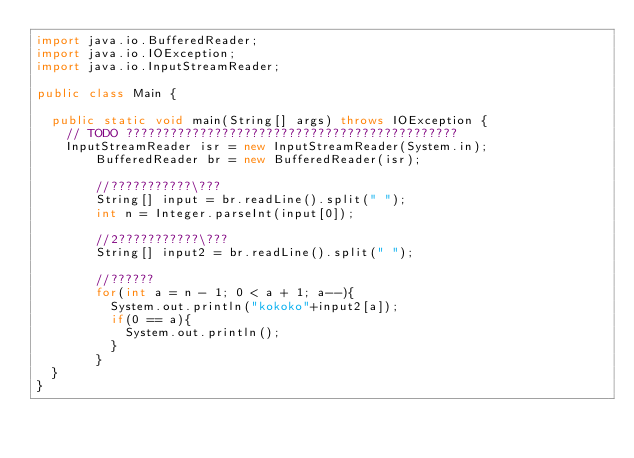Convert code to text. <code><loc_0><loc_0><loc_500><loc_500><_Java_>import java.io.BufferedReader;
import java.io.IOException;
import java.io.InputStreamReader;

public class Main {

	public static void main(String[] args) throws IOException {
		// TODO ?????????????????????????????????????????????
		InputStreamReader isr = new InputStreamReader(System.in);
        BufferedReader br = new BufferedReader(isr);

        //???????????\???
        String[] input = br.readLine().split(" ");
        int n = Integer.parseInt(input[0]);

        //2???????????\???
        String[] input2 = br.readLine().split(" ");

        //??????
        for(int a = n - 1; 0 < a + 1; a--){
        	System.out.println("kokoko"+input2[a]);
        	if(0 == a){
        		System.out.println();
        	}
        }
	}
}</code> 